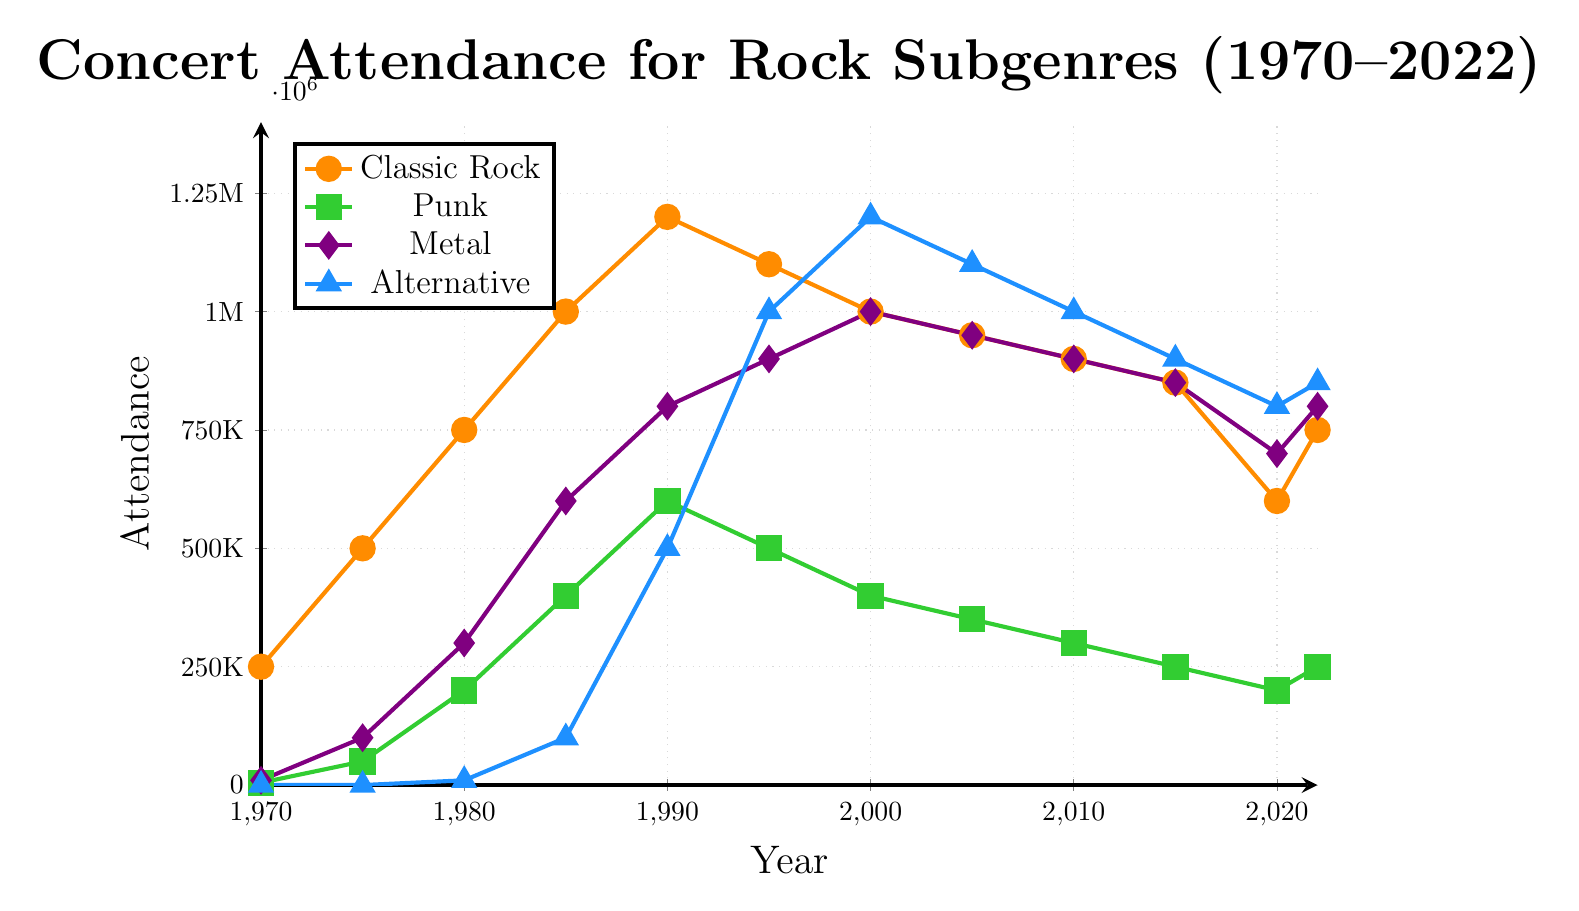What was the concert attendance for Classic Rock and Alternative in 1985? To find the attendance for Classic Rock and Alternative in 1985, refer to their respective data points for that year from the chart. Classic Rock had 1,000,000 attendees, and Alternative had 100,000 attendees.
Answer: Classic Rock: 1,000,000, Alternative: 100,000 How does the attendance for Punk in 1980 compare to that in 2005? Check the attendance for Punk in both years. In 1980, it was 200,000, and in 2005, it was 350,000. Hence, the attendance in 2005 was higher than in 1980.
Answer: 2005 > 1980 Which rock subgenre had the highest concert attendance in 2022? Look at the attendance values for each subgenre in 2022. Classic Rock had 750,000, Punk had 250,000, Metal had 800,000, and Alternative had 850,000. Alternative had the highest attendance.
Answer: Alternative What was the trend for Metal concert attendance from 1975 to 1995? Observe the Metal line from 1975 to 1995. The attendance increased from 100,000 in 1975 to 900,000 in 1995, showing a steady upward trend.
Answer: Upward trend Calculate the average attendance for Classic Rock over the entire period. Sum the attendance values for Classic Rock from 1970 to 2022 and divide by the number of data points. (250,000 + 500,000 + 750,000 + 1,000,000 + 1,200,000 + 1,100,000 + 1,000,000 + 950,000 + 900,000 + 850,000 + 600,000 + 750,000) / 12 = 871,666.67
Answer: 871,666.67 Compare the decrease in concert attendance for Punk and Metal from 2010 to 2015. In 2010, Punk had 300,000, and Metal had 900,000. In 2015, Punk had 250,000, and Metal had 850,000. Therefore, the decrease for Punk was 50,000 (300,000 - 250,000) and for Metal, it was also 50,000 (900,000 - 850,000).
Answer: Equal decrease of 50,000 Between which years did Alternative rock experience its fastest growth in concert attendance? To determine the fastest growth, compare the difference in attendance between consecutive years. The largest increase occurred between 1990 (500,000) and 1995 (1,000,000), which was an increase of 500,000.
Answer: Between 1990 and 1995 What visual color is used to represent Classic Rock, and how does its trend appear overall from 1970 to 2022? Classic Rock is represented by an orange color. Over the period from 1970 to 2022, its trend shows an initial increase until about 1990, then a general decline with minor fluctuations afterwards.
Answer: Orange, rising then declining trend How did the concert attendance for Classic Rock change from 2015 to 2020, and then to 2022? From 2015 to 2020, Classic Rock's attendance decreased from 850,000 to 600,000. From 2020 to 2022, it increased again to 750,000.
Answer: Decrease then increase What is the difference in attendance between the highest and lowest years for Metal? To find the difference, identify the highest attendance for Metal which is 1,000,000 in 2000 and the lowest which is 10,000 in 1970. The difference is 1,000,000 - 10,000 = 990,000.
Answer: 990,000 